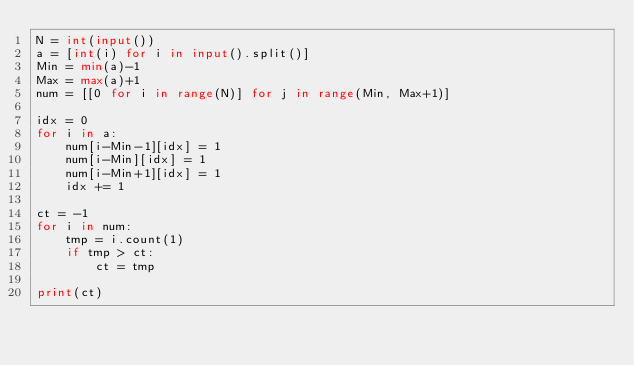<code> <loc_0><loc_0><loc_500><loc_500><_Python_>N = int(input())
a = [int(i) for i in input().split()]
Min = min(a)-1
Max = max(a)+1
num = [[0 for i in range(N)] for j in range(Min, Max+1)]

idx = 0
for i in a:
    num[i-Min-1][idx] = 1
    num[i-Min][idx] = 1
    num[i-Min+1][idx] = 1
    idx += 1

ct = -1
for i in num:
    tmp = i.count(1)
    if tmp > ct:
        ct = tmp
        
print(ct)
        </code> 